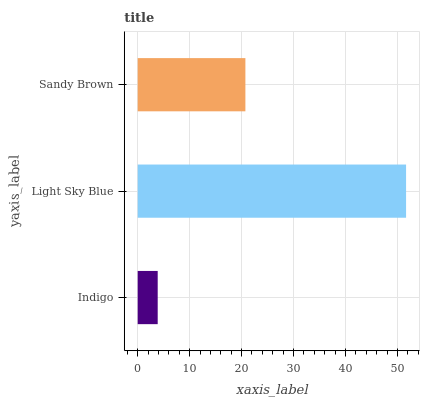Is Indigo the minimum?
Answer yes or no. Yes. Is Light Sky Blue the maximum?
Answer yes or no. Yes. Is Sandy Brown the minimum?
Answer yes or no. No. Is Sandy Brown the maximum?
Answer yes or no. No. Is Light Sky Blue greater than Sandy Brown?
Answer yes or no. Yes. Is Sandy Brown less than Light Sky Blue?
Answer yes or no. Yes. Is Sandy Brown greater than Light Sky Blue?
Answer yes or no. No. Is Light Sky Blue less than Sandy Brown?
Answer yes or no. No. Is Sandy Brown the high median?
Answer yes or no. Yes. Is Sandy Brown the low median?
Answer yes or no. Yes. Is Indigo the high median?
Answer yes or no. No. Is Indigo the low median?
Answer yes or no. No. 